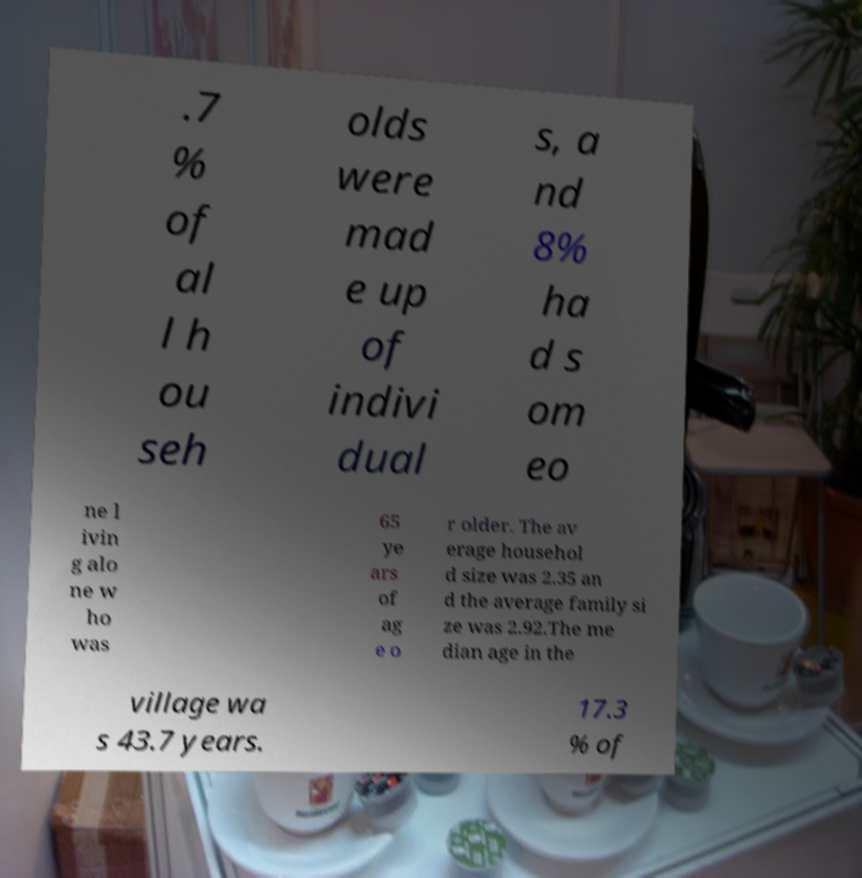There's text embedded in this image that I need extracted. Can you transcribe it verbatim? .7 % of al l h ou seh olds were mad e up of indivi dual s, a nd 8% ha d s om eo ne l ivin g alo ne w ho was 65 ye ars of ag e o r older. The av erage househol d size was 2.35 an d the average family si ze was 2.92.The me dian age in the village wa s 43.7 years. 17.3 % of 